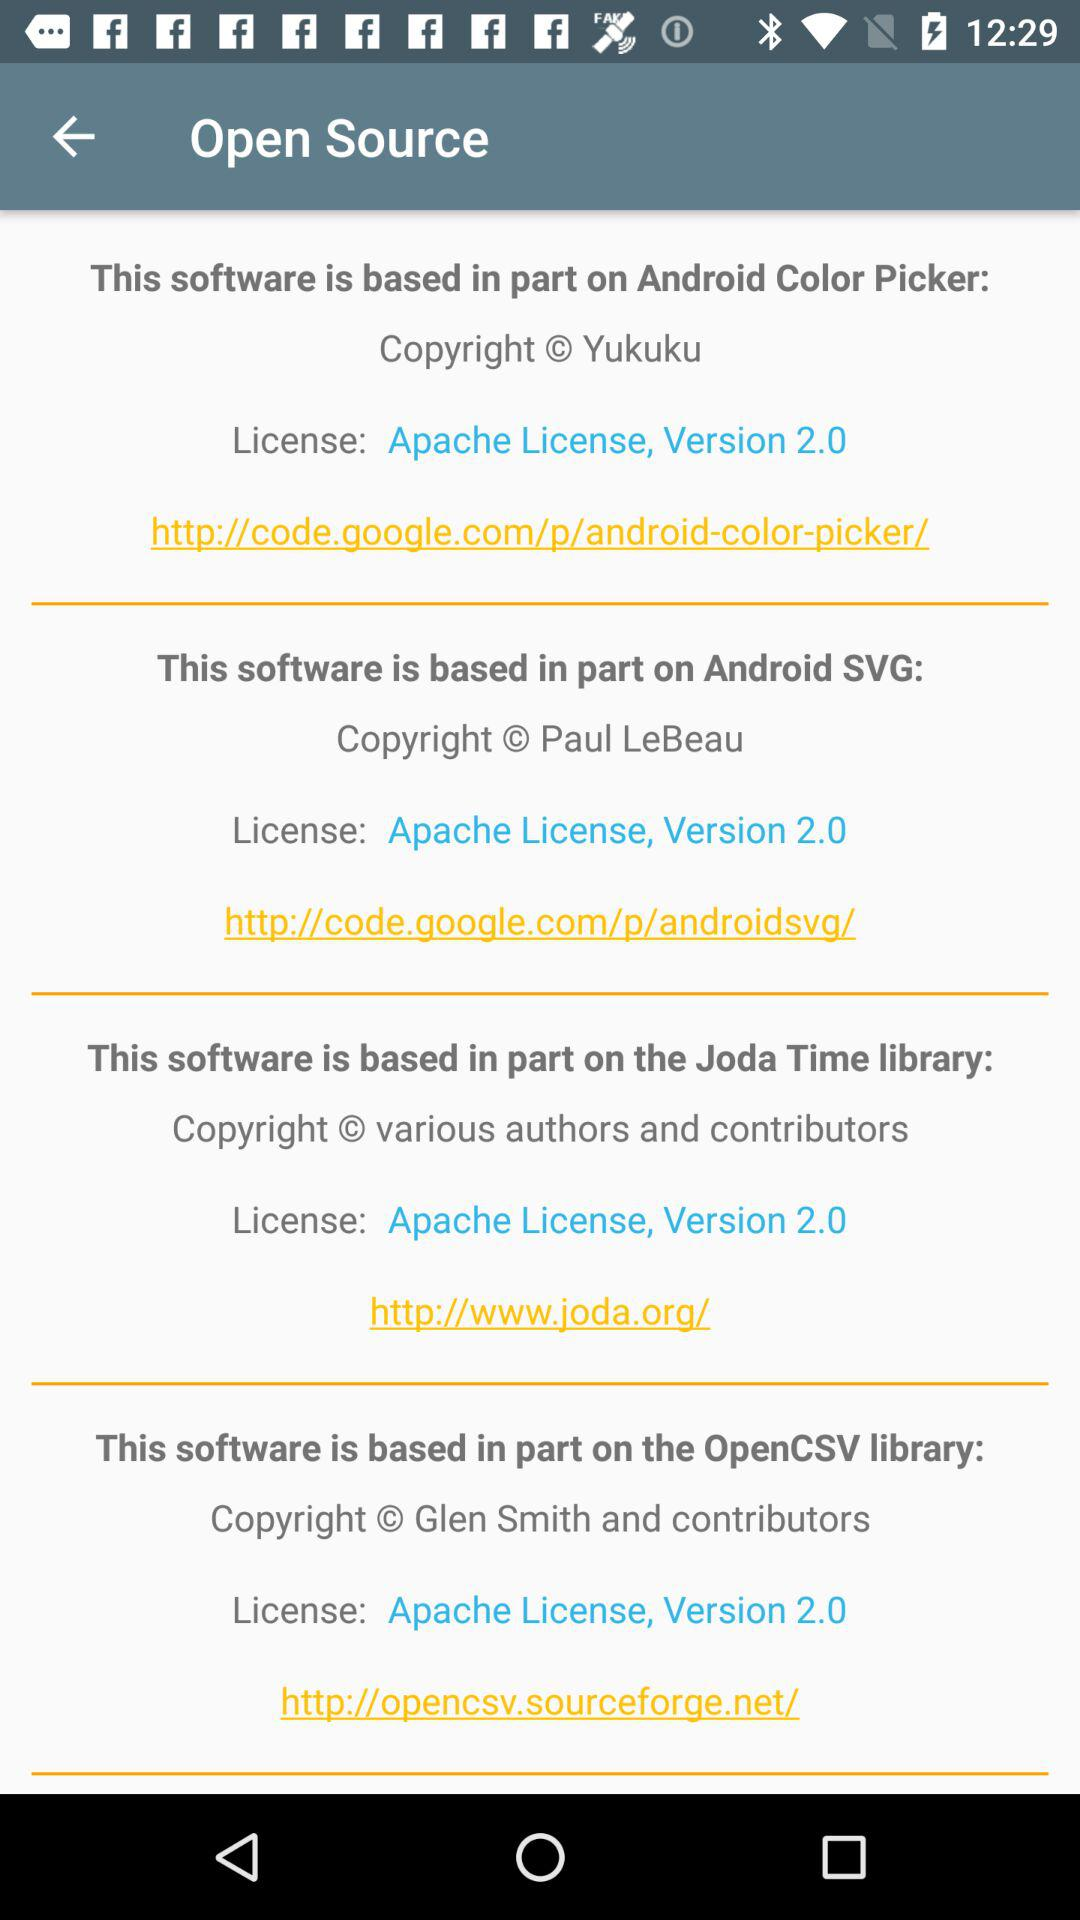What is the current version of the Apache License? The current version of the Apache License is 2.0. 